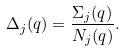Convert formula to latex. <formula><loc_0><loc_0><loc_500><loc_500>\Delta _ { j } ( q ) = \frac { \Sigma _ { j } ( q ) } { N _ { j } ( q ) } .</formula> 